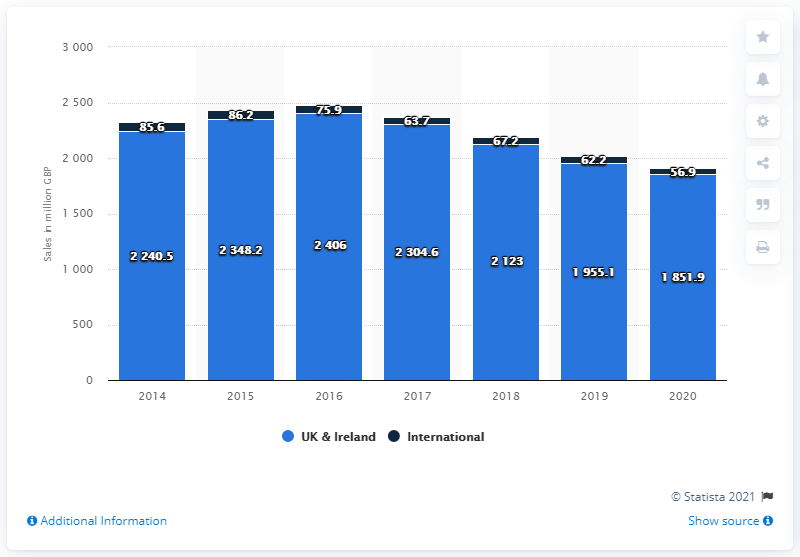How much money did Next plc generate through its UK and Ireland stores in the year ended January 2020? According to the bar chart shown in the image, Next plc generated £1,851.9 million through its UK and Ireland stores in the year that ended in January 2020. This figure is derived from the last bar for UK & Ireland on the chart, which indicates a slight decrease from the previous year's earnings of £1,955.1 million. 